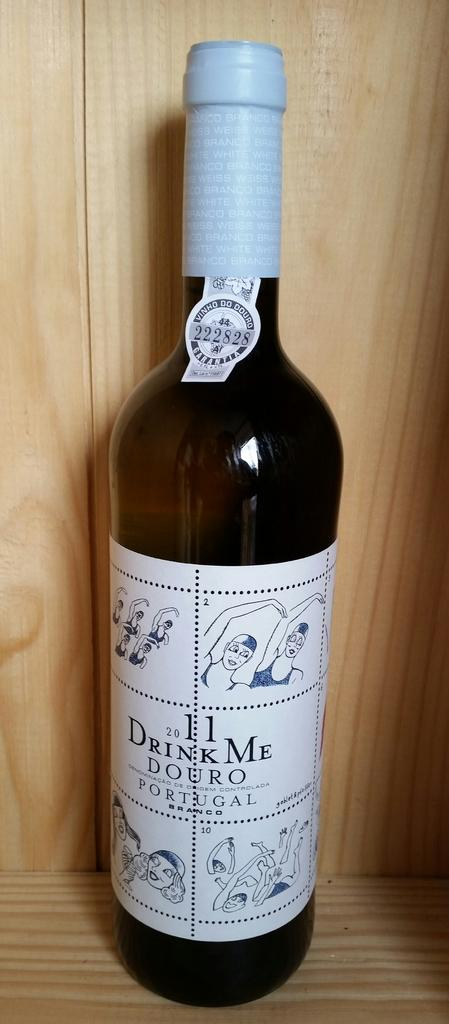Provide a one-sentence caption for the provided image. A bottle of Drink Me Douro Portugal still sealed. 